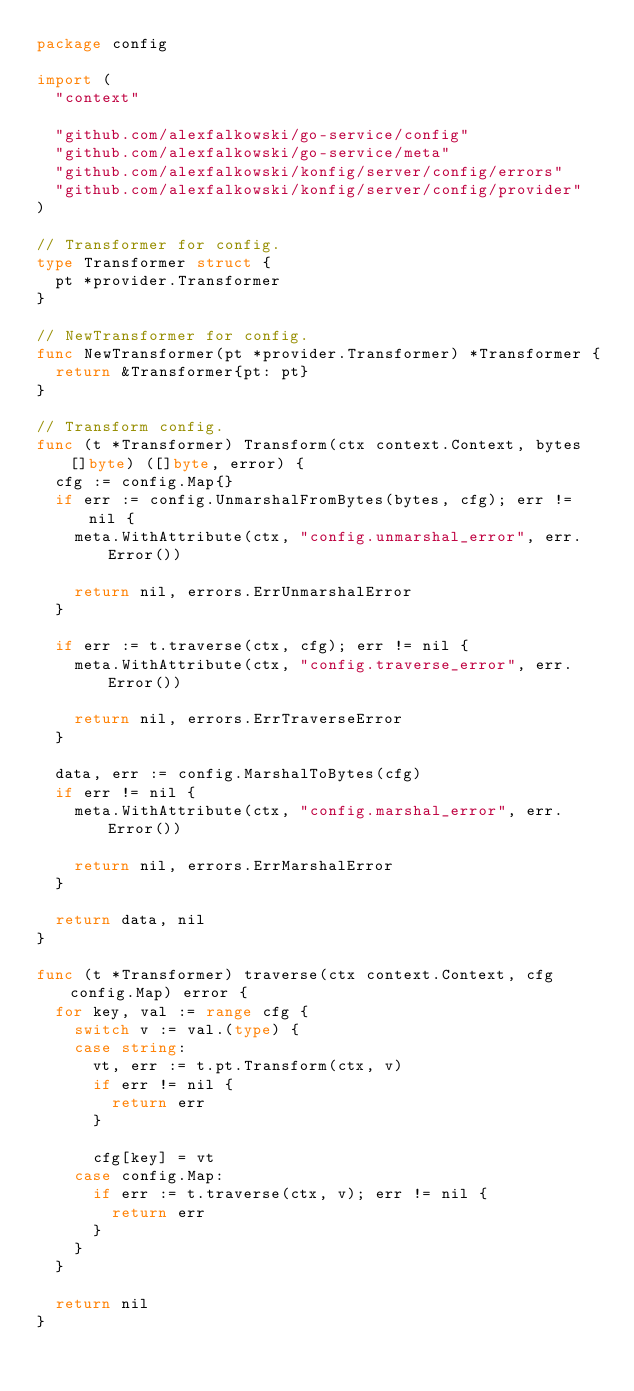Convert code to text. <code><loc_0><loc_0><loc_500><loc_500><_Go_>package config

import (
	"context"

	"github.com/alexfalkowski/go-service/config"
	"github.com/alexfalkowski/go-service/meta"
	"github.com/alexfalkowski/konfig/server/config/errors"
	"github.com/alexfalkowski/konfig/server/config/provider"
)

// Transformer for config.
type Transformer struct {
	pt *provider.Transformer
}

// NewTransformer for config.
func NewTransformer(pt *provider.Transformer) *Transformer {
	return &Transformer{pt: pt}
}

// Transform config.
func (t *Transformer) Transform(ctx context.Context, bytes []byte) ([]byte, error) {
	cfg := config.Map{}
	if err := config.UnmarshalFromBytes(bytes, cfg); err != nil {
		meta.WithAttribute(ctx, "config.unmarshal_error", err.Error())

		return nil, errors.ErrUnmarshalError
	}

	if err := t.traverse(ctx, cfg); err != nil {
		meta.WithAttribute(ctx, "config.traverse_error", err.Error())

		return nil, errors.ErrTraverseError
	}

	data, err := config.MarshalToBytes(cfg)
	if err != nil {
		meta.WithAttribute(ctx, "config.marshal_error", err.Error())

		return nil, errors.ErrMarshalError
	}

	return data, nil
}

func (t *Transformer) traverse(ctx context.Context, cfg config.Map) error {
	for key, val := range cfg {
		switch v := val.(type) {
		case string:
			vt, err := t.pt.Transform(ctx, v)
			if err != nil {
				return err
			}

			cfg[key] = vt
		case config.Map:
			if err := t.traverse(ctx, v); err != nil {
				return err
			}
		}
	}

	return nil
}
</code> 